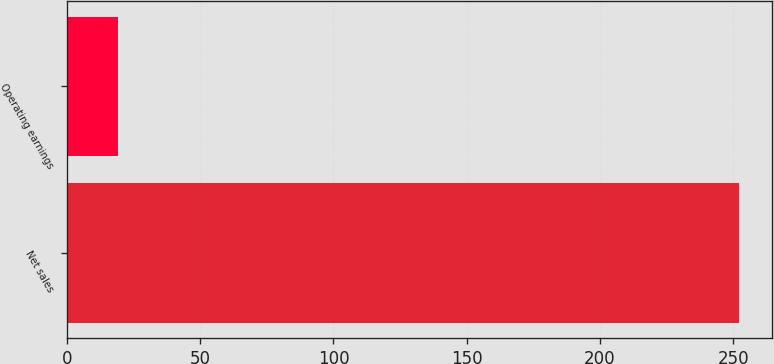<chart> <loc_0><loc_0><loc_500><loc_500><bar_chart><fcel>Net sales<fcel>Operating earnings<nl><fcel>252<fcel>19<nl></chart> 